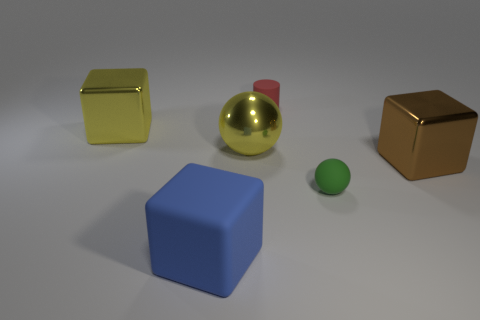What do you think the different sizes and shapes of these objects could represent? The varied sizes and shapes could symbolically represent diversity or a hierarchy. If this is an artistic composition, the cubes might represent structure and order, while the spheres could symbolize harmony and continuity. The size differences may imply importance or focus, with the larger objects drawing more attention and the smaller ones being secondary. Do the colors have any particular meaning? Colors may be chosen to convey emotions or concepts. Gold often symbolizes wealth or success, while blue can represent calmness or stability. The choice of these colors could be purely aesthetic, to create visual interest, or could be thematic, possibly alluding to concepts like value and trustworthiness. 